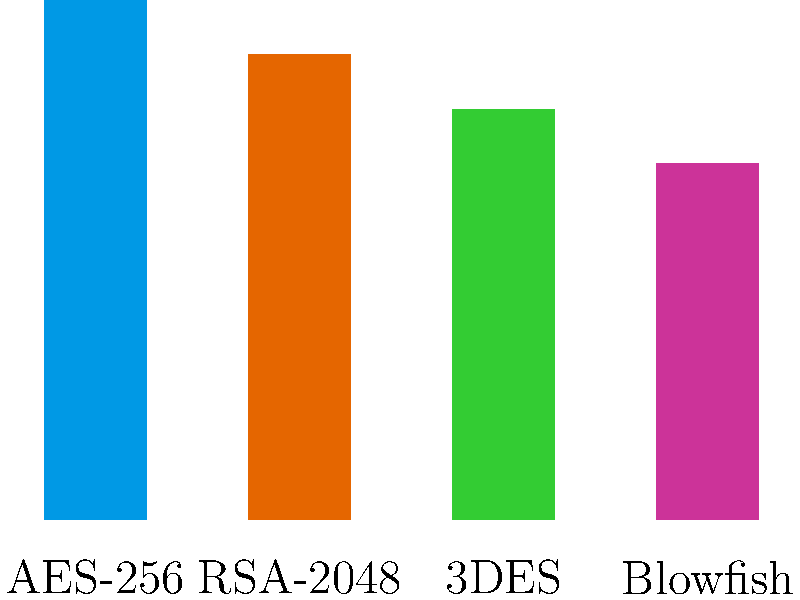Based on the bar chart comparing different encryption methods, which encryption algorithm provides the highest level of security for protecting sensitive financial data transmitted through APIs? To determine which encryption algorithm provides the highest level of security, we need to analyze the bar chart:

1. The chart compares four encryption methods: AES-256, RSA-2048, 3DES, and Blowfish.
2. The y-axis represents the encryption strength as a percentage.
3. Examining the bars:
   - AES-256: Approximately 95% strength
   - RSA-2048: Approximately 85% strength
   - 3DES: Approximately 75% strength
   - Blowfish: Approximately 65% strength

4. AES-256 (Advanced Encryption Standard with 256-bit key) has the highest bar, indicating the strongest encryption.
5. In the context of financial institutions and API security:
   - AES-256 is widely recognized as a secure symmetric encryption algorithm.
   - It is approved by the U.S. National Institute of Standards and Technology (NIST) for protecting classified information.
   - The 256-bit key length provides a very high level of security against brute-force attacks.

Therefore, based on the information provided in the bar chart, AES-256 offers the highest level of security for protecting sensitive financial data transmitted through APIs.
Answer: AES-256 